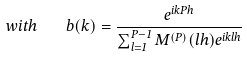<formula> <loc_0><loc_0><loc_500><loc_500>w i t h \quad b ( k ) = \frac { e ^ { i k P h } } { \sum _ { l = 1 } ^ { P - 1 } M ^ { ( P ) } ( l h ) e ^ { i k l h } }</formula> 